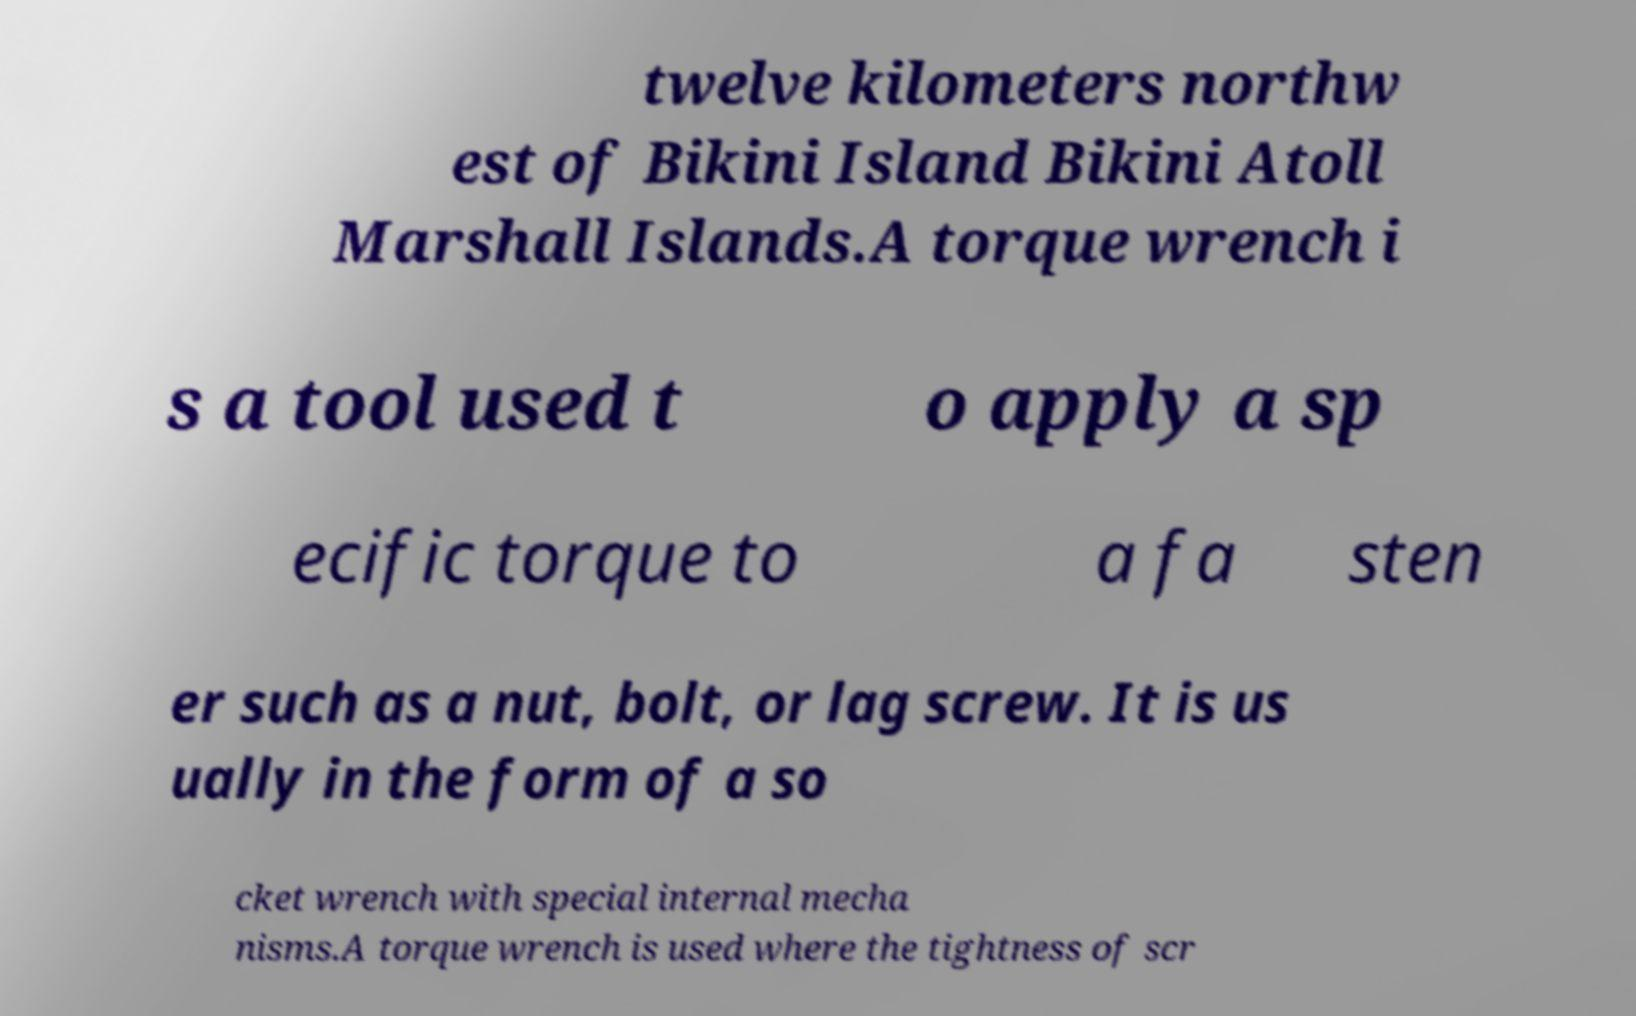I need the written content from this picture converted into text. Can you do that? twelve kilometers northw est of Bikini Island Bikini Atoll Marshall Islands.A torque wrench i s a tool used t o apply a sp ecific torque to a fa sten er such as a nut, bolt, or lag screw. It is us ually in the form of a so cket wrench with special internal mecha nisms.A torque wrench is used where the tightness of scr 